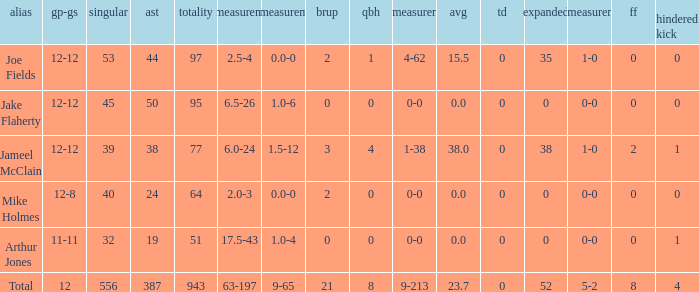How many yards for the player with tfl-yds of 2.5-4? 4-62. 